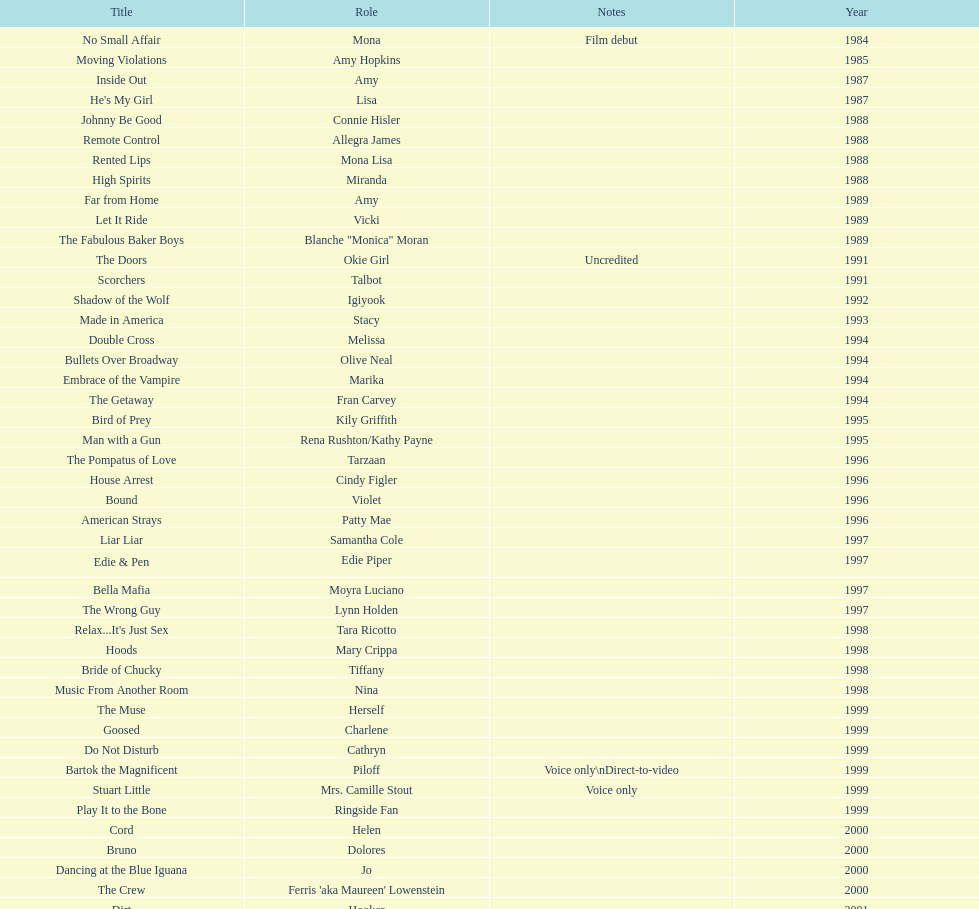Which movie was also a film debut? No Small Affair. 